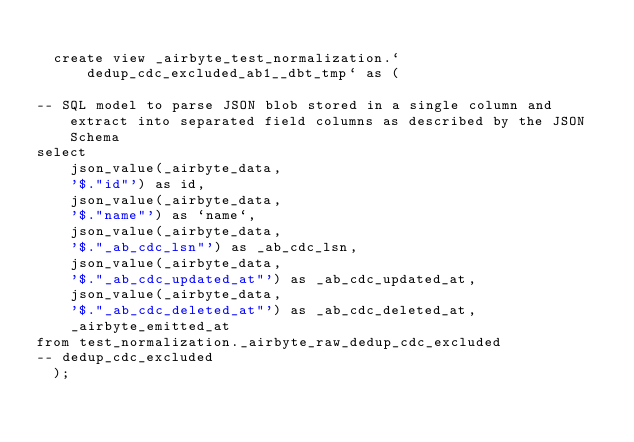<code> <loc_0><loc_0><loc_500><loc_500><_SQL_>
  create view _airbyte_test_normalization.`dedup_cdc_excluded_ab1__dbt_tmp` as (
    
-- SQL model to parse JSON blob stored in a single column and extract into separated field columns as described by the JSON Schema
select
    json_value(_airbyte_data, 
    '$."id"') as id,
    json_value(_airbyte_data, 
    '$."name"') as `name`,
    json_value(_airbyte_data, 
    '$."_ab_cdc_lsn"') as _ab_cdc_lsn,
    json_value(_airbyte_data, 
    '$."_ab_cdc_updated_at"') as _ab_cdc_updated_at,
    json_value(_airbyte_data, 
    '$."_ab_cdc_deleted_at"') as _ab_cdc_deleted_at,
    _airbyte_emitted_at
from test_normalization._airbyte_raw_dedup_cdc_excluded
-- dedup_cdc_excluded
  );
</code> 